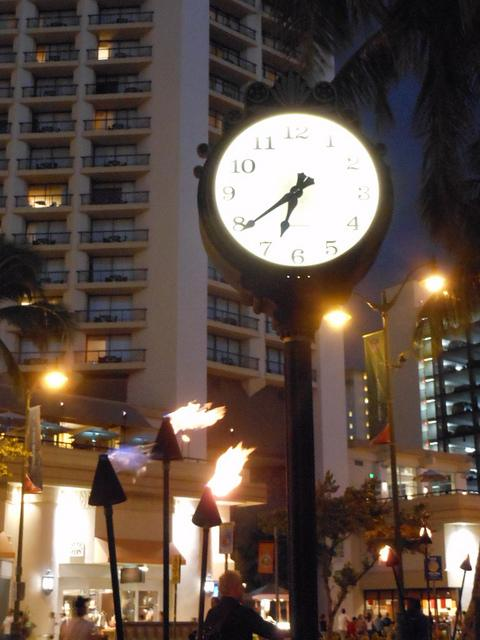In the event of a fire what could be blamed?

Choices:
A) smokers
B) clock
C) lights
D) torch torch 